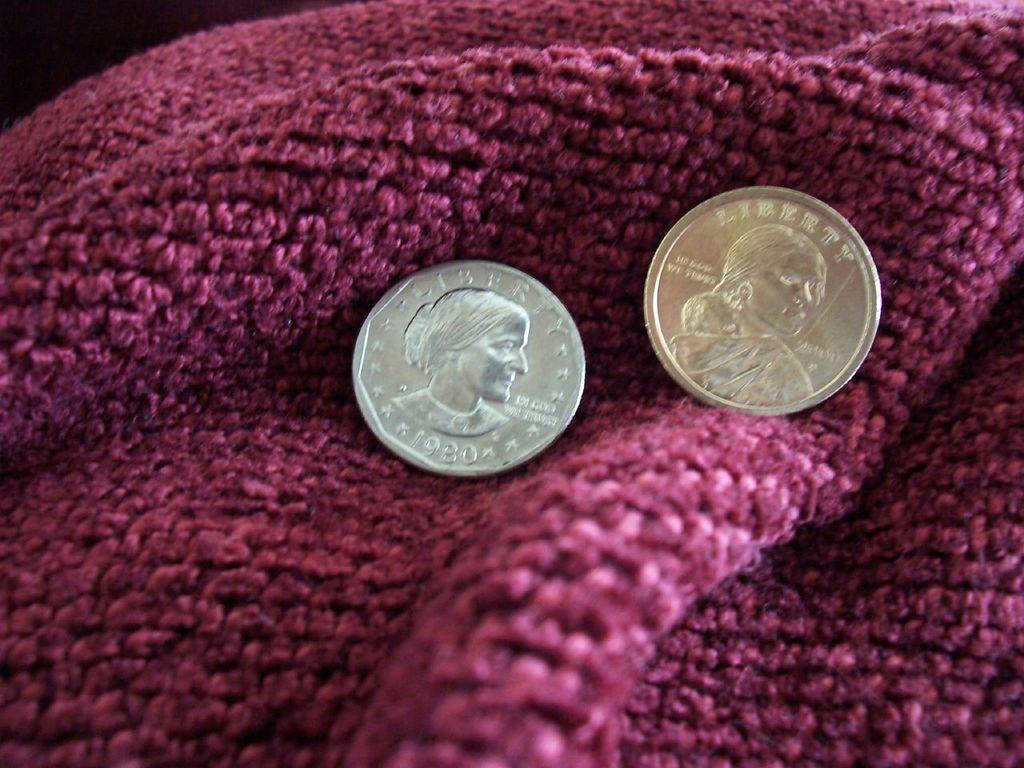<image>
Offer a succinct explanation of the picture presented. the back of two coins reading Liberty and In God We Trust on a maroon towel 